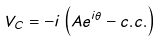<formula> <loc_0><loc_0><loc_500><loc_500>V _ { C } = - i \left ( A e ^ { i \theta } - c . c . \right )</formula> 